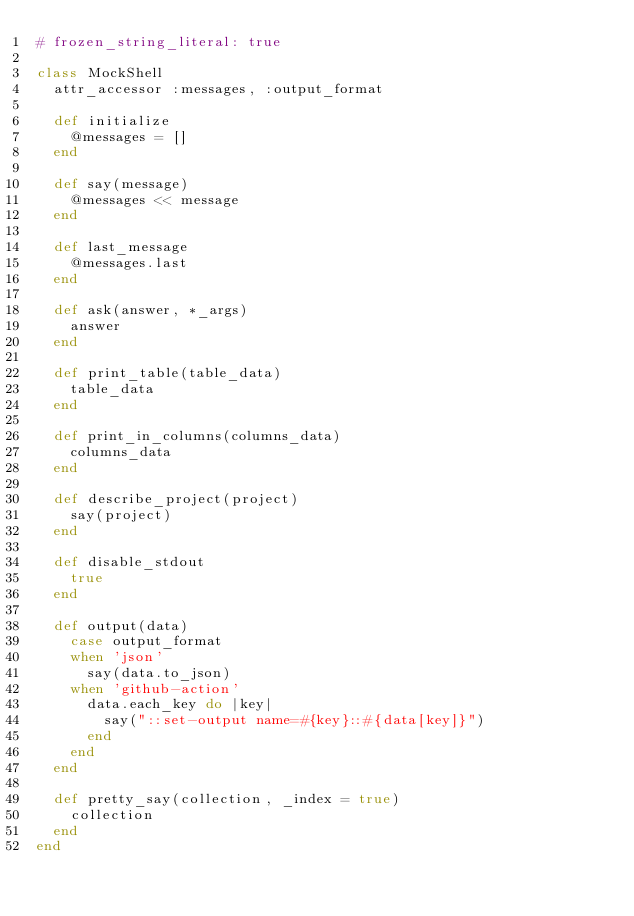Convert code to text. <code><loc_0><loc_0><loc_500><loc_500><_Ruby_># frozen_string_literal: true

class MockShell
  attr_accessor :messages, :output_format

  def initialize
    @messages = []
  end

  def say(message)
    @messages << message
  end

  def last_message
    @messages.last
  end

  def ask(answer, *_args)
    answer
  end

  def print_table(table_data)
    table_data
  end

  def print_in_columns(columns_data)
    columns_data
  end

  def describe_project(project)
    say(project)
  end

  def disable_stdout
    true
  end

  def output(data)
    case output_format
    when 'json'
      say(data.to_json)
    when 'github-action'
      data.each_key do |key|
        say("::set-output name=#{key}::#{data[key]}")
      end
    end
  end

  def pretty_say(collection, _index = true)
    collection
  end
end
</code> 